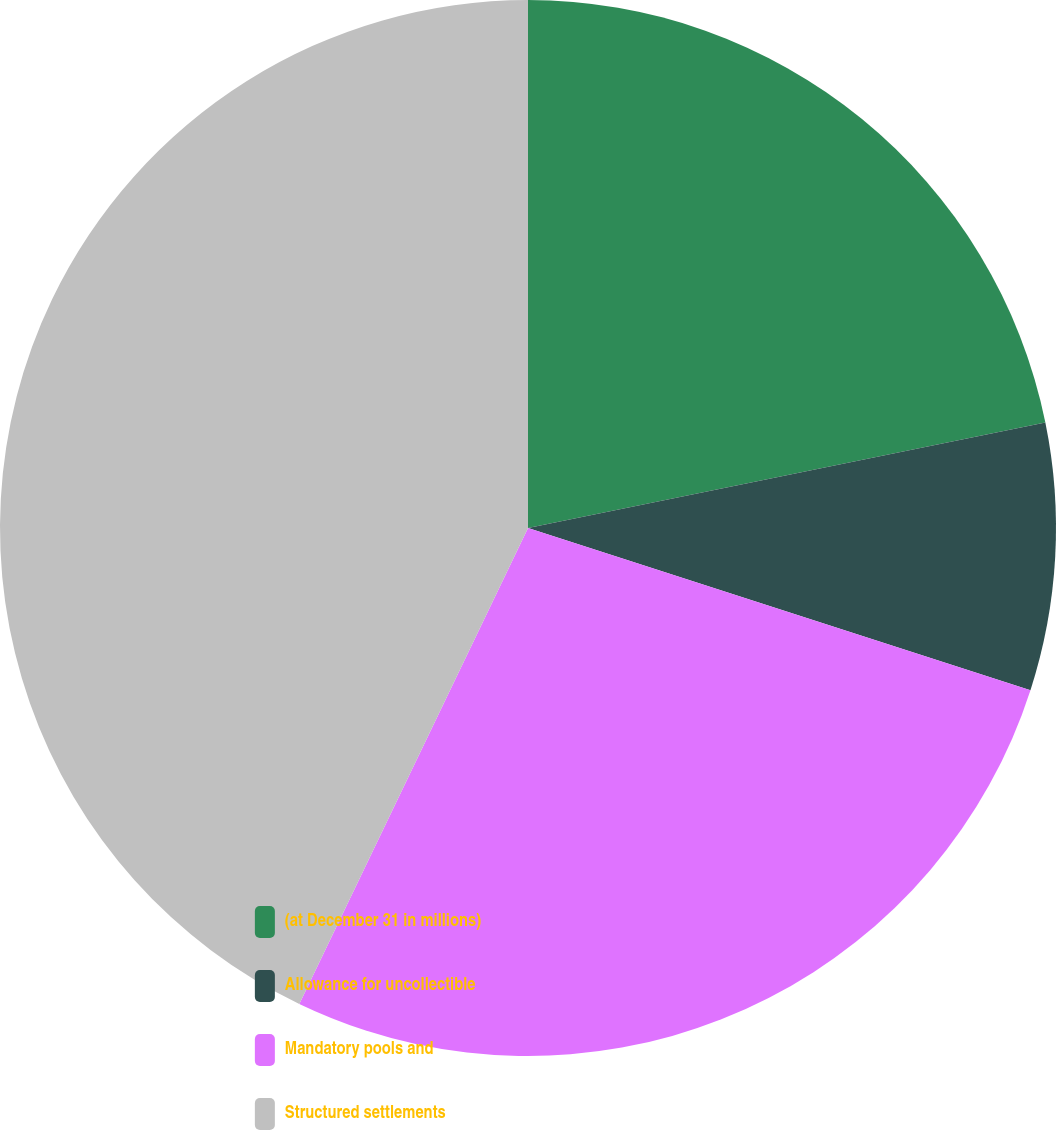<chart> <loc_0><loc_0><loc_500><loc_500><pie_chart><fcel>(at December 31 in millions)<fcel>Allowance for uncollectible<fcel>Mandatory pools and<fcel>Structured settlements<nl><fcel>21.8%<fcel>8.17%<fcel>27.16%<fcel>42.87%<nl></chart> 